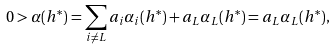Convert formula to latex. <formula><loc_0><loc_0><loc_500><loc_500>0 > \alpha ( h ^ { \ast } ) = \sum _ { i \ne L } a _ { i } { \alpha } _ { i } ( h ^ { \ast } ) + a _ { L } { \alpha } _ { L } ( h ^ { \ast } ) = a _ { L } { \alpha } _ { L } ( h ^ { \ast } ) ,</formula> 